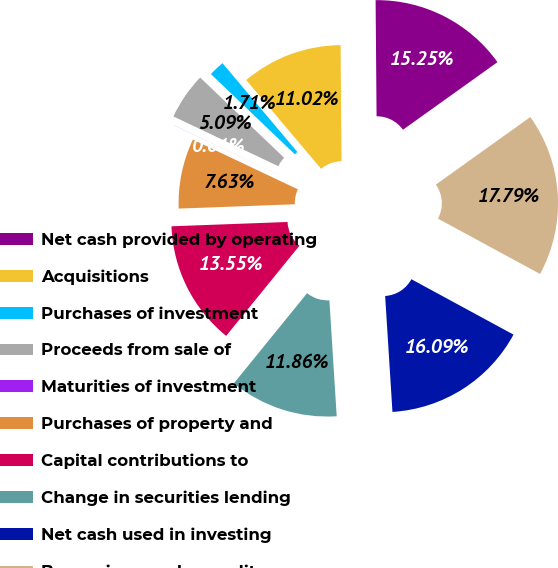Convert chart. <chart><loc_0><loc_0><loc_500><loc_500><pie_chart><fcel>Net cash provided by operating<fcel>Acquisitions<fcel>Purchases of investment<fcel>Proceeds from sale of<fcel>Maturities of investment<fcel>Purchases of property and<fcel>Capital contributions to<fcel>Change in securities lending<fcel>Net cash used in investing<fcel>Borrowings under credit<nl><fcel>15.25%<fcel>11.02%<fcel>1.71%<fcel>5.09%<fcel>0.01%<fcel>7.63%<fcel>13.55%<fcel>11.86%<fcel>16.09%<fcel>17.79%<nl></chart> 